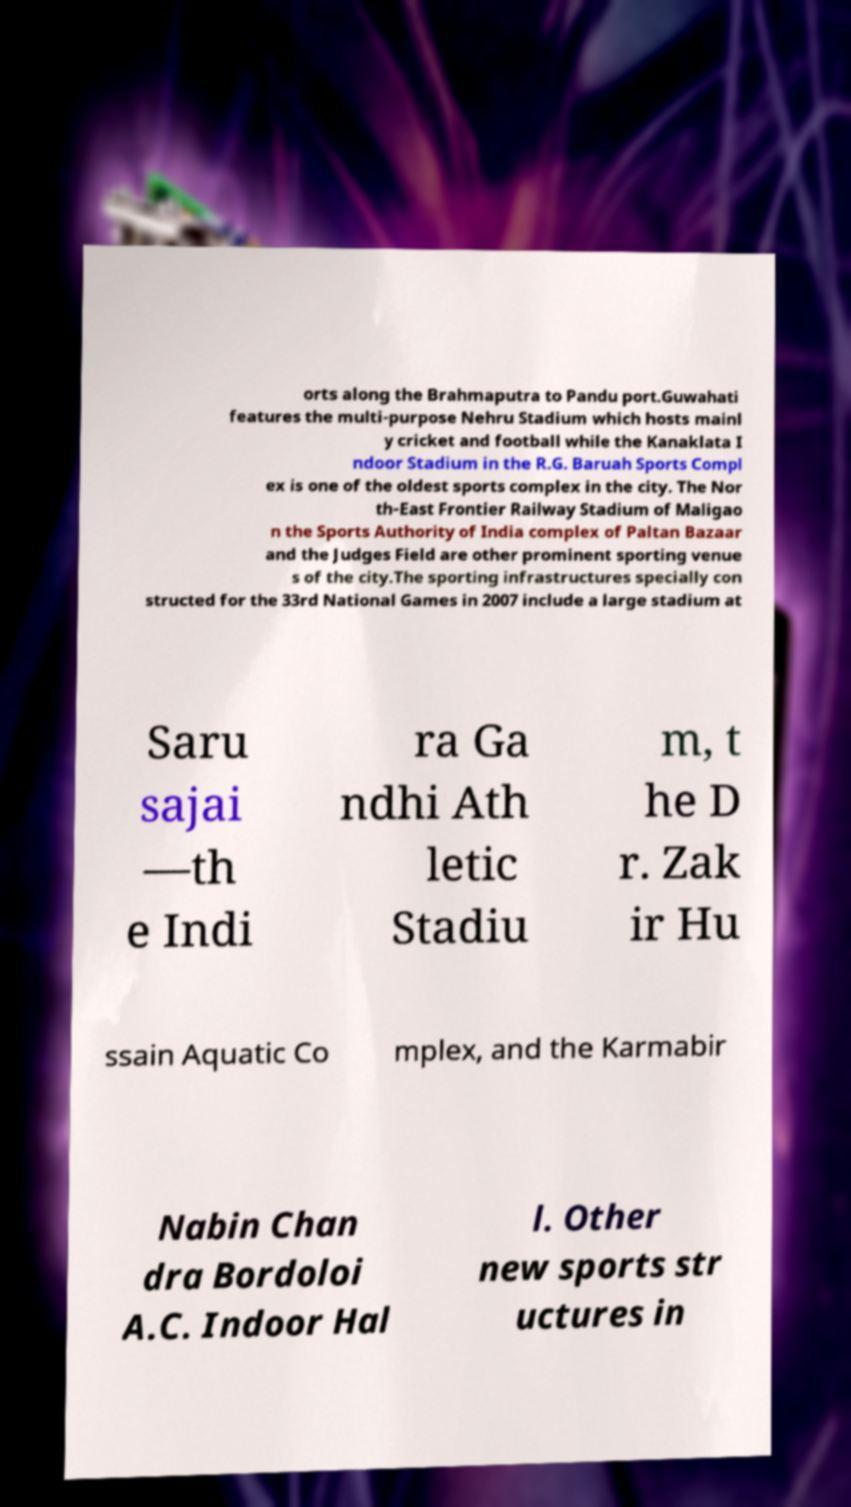Please identify and transcribe the text found in this image. orts along the Brahmaputra to Pandu port.Guwahati features the multi-purpose Nehru Stadium which hosts mainl y cricket and football while the Kanaklata I ndoor Stadium in the R.G. Baruah Sports Compl ex is one of the oldest sports complex in the city. The Nor th-East Frontier Railway Stadium of Maligao n the Sports Authority of India complex of Paltan Bazaar and the Judges Field are other prominent sporting venue s of the city.The sporting infrastructures specially con structed for the 33rd National Games in 2007 include a large stadium at Saru sajai —th e Indi ra Ga ndhi Ath letic Stadiu m, t he D r. Zak ir Hu ssain Aquatic Co mplex, and the Karmabir Nabin Chan dra Bordoloi A.C. Indoor Hal l. Other new sports str uctures in 